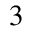Convert formula to latex. <formula><loc_0><loc_0><loc_500><loc_500>^ { 3 }</formula> 